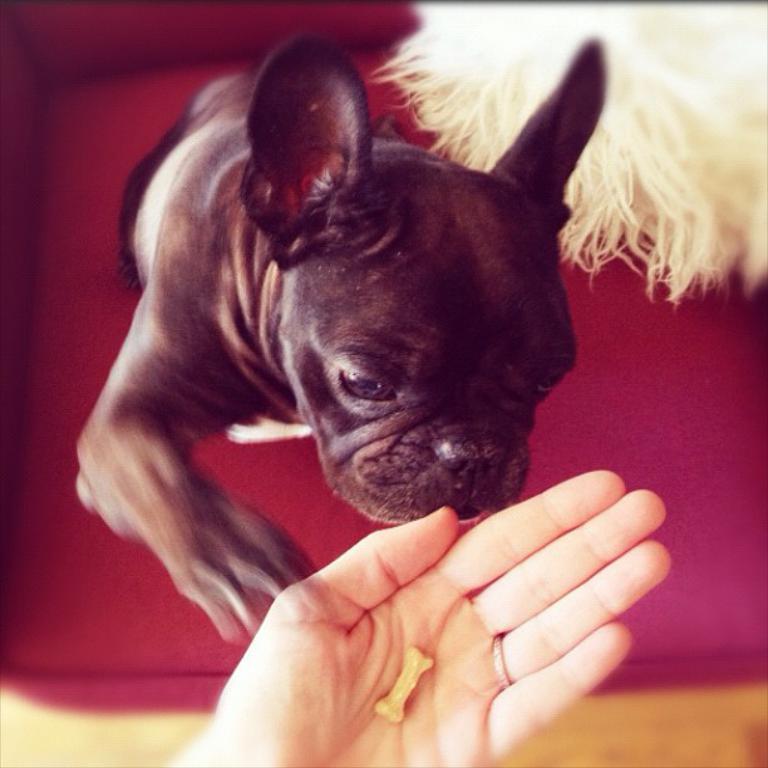How would you summarize this image in a sentence or two? In the image we can see a dog and human hand, and the corners of the image are dark. 